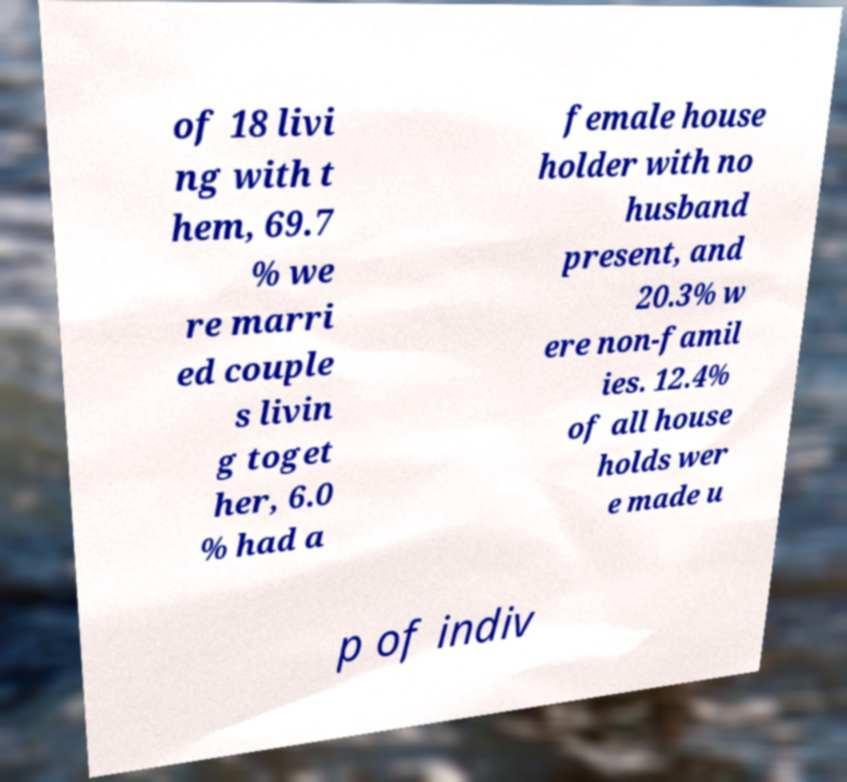For documentation purposes, I need the text within this image transcribed. Could you provide that? of 18 livi ng with t hem, 69.7 % we re marri ed couple s livin g toget her, 6.0 % had a female house holder with no husband present, and 20.3% w ere non-famil ies. 12.4% of all house holds wer e made u p of indiv 